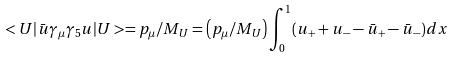Convert formula to latex. <formula><loc_0><loc_0><loc_500><loc_500>< U | \bar { u } \gamma _ { \mu } \gamma _ { 5 } u | U > = p _ { \mu } / M _ { U } = \left ( p _ { \mu } / M _ { U } \right ) \int ^ { 1 } _ { 0 } ( u _ { + } + u _ { - } - \bar { u } _ { + } - \bar { u } _ { - } ) d x</formula> 